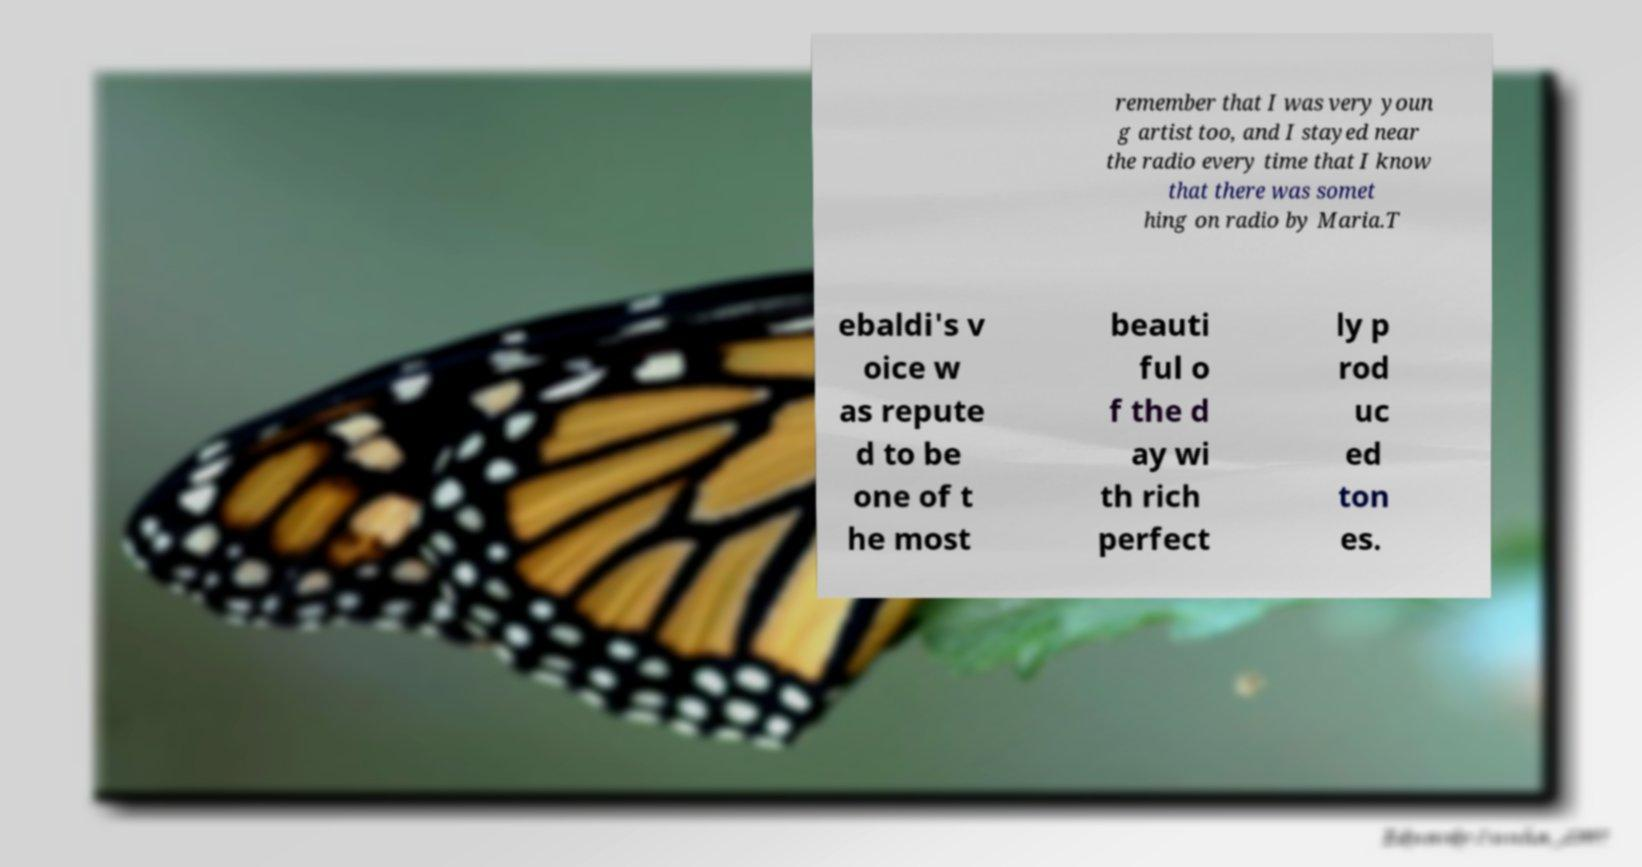There's text embedded in this image that I need extracted. Can you transcribe it verbatim? remember that I was very youn g artist too, and I stayed near the radio every time that I know that there was somet hing on radio by Maria.T ebaldi's v oice w as repute d to be one of t he most beauti ful o f the d ay wi th rich perfect ly p rod uc ed ton es. 